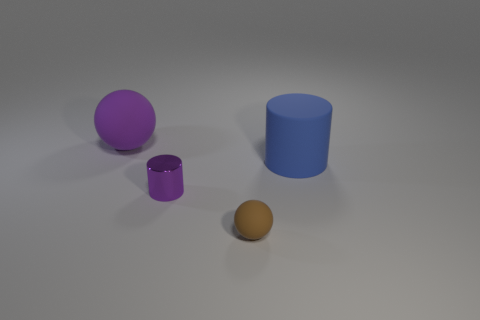There is a large thing left of the big blue thing; is its color the same as the matte ball that is in front of the big purple object?
Your response must be concise. No. Is there anything else that is the same color as the small metal cylinder?
Offer a very short reply. Yes. Is the number of large balls that are on the right side of the small brown ball less than the number of large gray metallic cylinders?
Your answer should be compact. No. What number of small blue things are there?
Your answer should be very brief. 0. There is a blue object; does it have the same shape as the object that is behind the large rubber cylinder?
Provide a short and direct response. No. Are there fewer big purple objects that are left of the big purple sphere than blue cylinders in front of the large blue rubber thing?
Provide a succinct answer. No. Are there any other things that are the same shape as the large purple matte object?
Ensure brevity in your answer.  Yes. Does the blue object have the same shape as the small purple object?
Keep it short and to the point. Yes. Is there any other thing that is the same material as the big blue object?
Your answer should be compact. Yes. The purple cylinder is what size?
Your answer should be very brief. Small. 